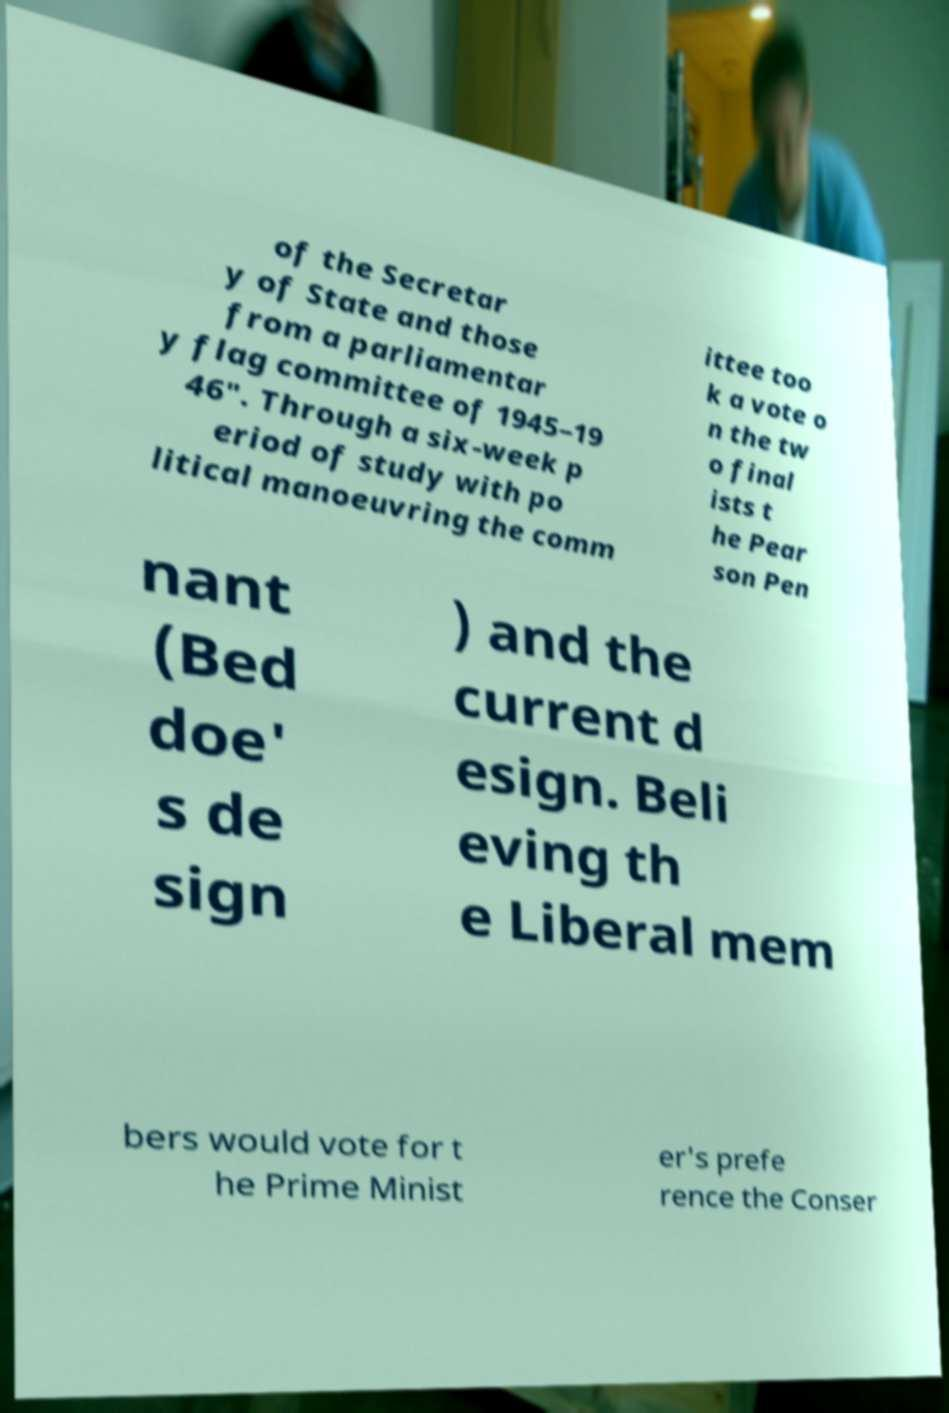Could you extract and type out the text from this image? of the Secretar y of State and those from a parliamentar y flag committee of 1945–19 46". Through a six-week p eriod of study with po litical manoeuvring the comm ittee too k a vote o n the tw o final ists t he Pear son Pen nant (Bed doe' s de sign ) and the current d esign. Beli eving th e Liberal mem bers would vote for t he Prime Minist er's prefe rence the Conser 